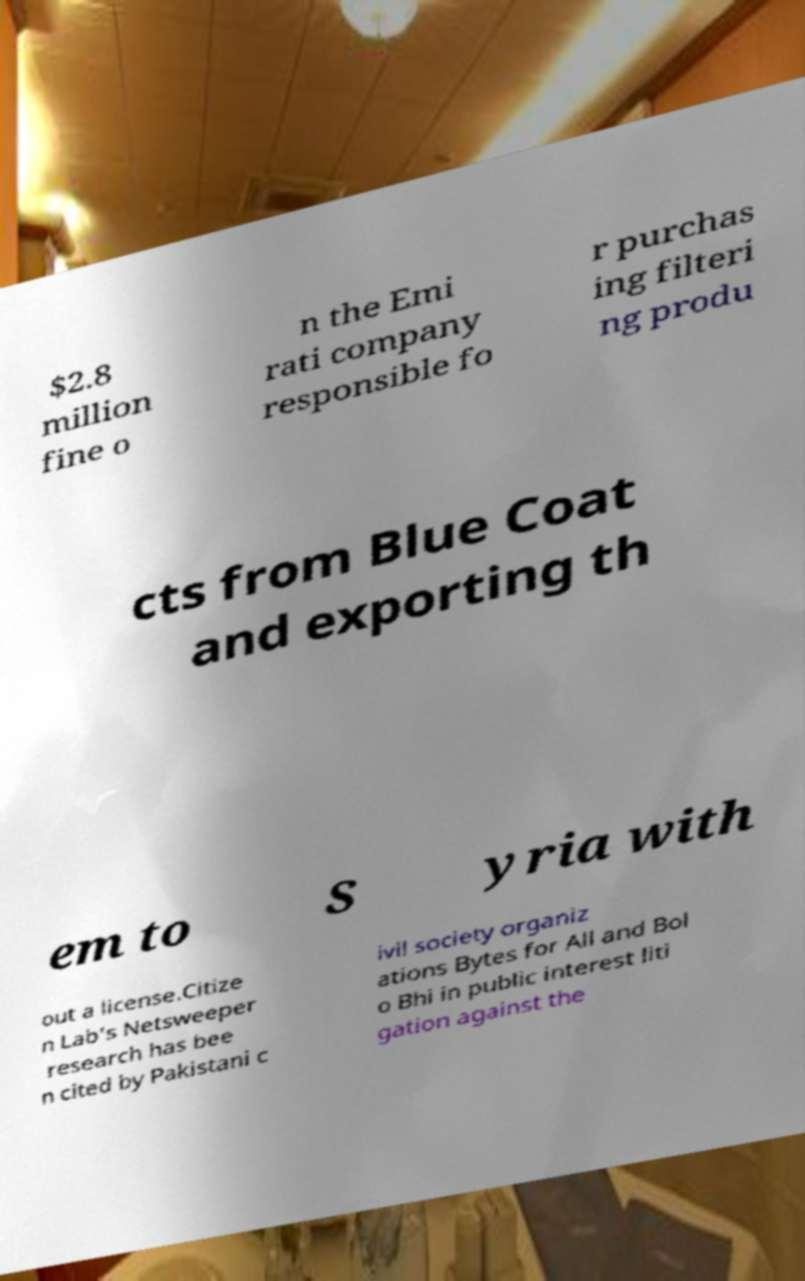Can you accurately transcribe the text from the provided image for me? $2.8 million fine o n the Emi rati company responsible fo r purchas ing filteri ng produ cts from Blue Coat and exporting th em to S yria with out a license.Citize n Lab's Netsweeper research has bee n cited by Pakistani c ivil society organiz ations Bytes for All and Bol o Bhi in public interest liti gation against the 